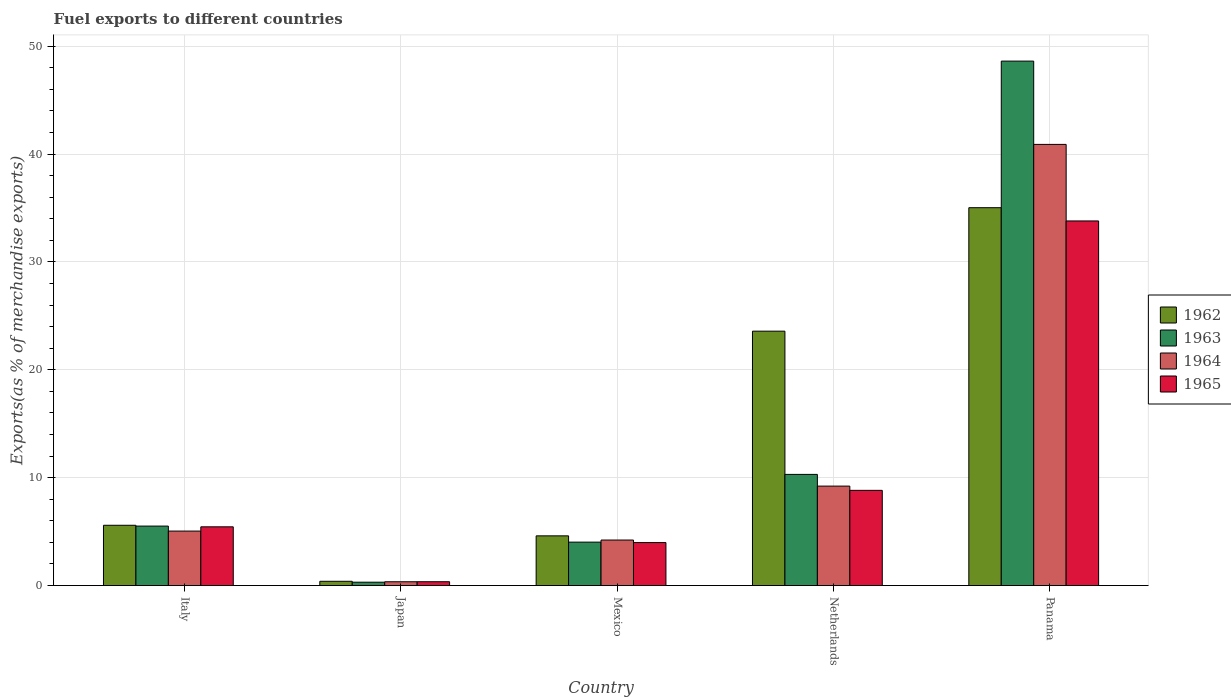How many different coloured bars are there?
Provide a short and direct response. 4. Are the number of bars per tick equal to the number of legend labels?
Your answer should be very brief. Yes. Are the number of bars on each tick of the X-axis equal?
Your response must be concise. Yes. How many bars are there on the 5th tick from the left?
Offer a very short reply. 4. How many bars are there on the 4th tick from the right?
Offer a very short reply. 4. What is the percentage of exports to different countries in 1964 in Japan?
Your response must be concise. 0.35. Across all countries, what is the maximum percentage of exports to different countries in 1965?
Keep it short and to the point. 33.8. Across all countries, what is the minimum percentage of exports to different countries in 1964?
Provide a short and direct response. 0.35. In which country was the percentage of exports to different countries in 1962 maximum?
Your response must be concise. Panama. What is the total percentage of exports to different countries in 1964 in the graph?
Your answer should be very brief. 59.74. What is the difference between the percentage of exports to different countries in 1965 in Japan and that in Mexico?
Your response must be concise. -3.63. What is the difference between the percentage of exports to different countries in 1964 in Japan and the percentage of exports to different countries in 1965 in Netherlands?
Ensure brevity in your answer.  -8.47. What is the average percentage of exports to different countries in 1964 per country?
Offer a terse response. 11.95. What is the difference between the percentage of exports to different countries of/in 1965 and percentage of exports to different countries of/in 1962 in Italy?
Provide a succinct answer. -0.14. What is the ratio of the percentage of exports to different countries in 1964 in Italy to that in Japan?
Your answer should be very brief. 14.31. Is the percentage of exports to different countries in 1965 in Japan less than that in Mexico?
Provide a short and direct response. Yes. Is the difference between the percentage of exports to different countries in 1965 in Italy and Japan greater than the difference between the percentage of exports to different countries in 1962 in Italy and Japan?
Your answer should be compact. No. What is the difference between the highest and the second highest percentage of exports to different countries in 1962?
Ensure brevity in your answer.  29.44. What is the difference between the highest and the lowest percentage of exports to different countries in 1965?
Give a very brief answer. 33.45. Is it the case that in every country, the sum of the percentage of exports to different countries in 1962 and percentage of exports to different countries in 1965 is greater than the sum of percentage of exports to different countries in 1964 and percentage of exports to different countries in 1963?
Give a very brief answer. No. What does the 4th bar from the left in Panama represents?
Offer a very short reply. 1965. What does the 4th bar from the right in Panama represents?
Make the answer very short. 1962. What is the difference between two consecutive major ticks on the Y-axis?
Offer a terse response. 10. Does the graph contain grids?
Your answer should be compact. Yes. How many legend labels are there?
Keep it short and to the point. 4. How are the legend labels stacked?
Give a very brief answer. Vertical. What is the title of the graph?
Provide a succinct answer. Fuel exports to different countries. What is the label or title of the Y-axis?
Offer a very short reply. Exports(as % of merchandise exports). What is the Exports(as % of merchandise exports) in 1962 in Italy?
Ensure brevity in your answer.  5.59. What is the Exports(as % of merchandise exports) of 1963 in Italy?
Your answer should be very brief. 5.51. What is the Exports(as % of merchandise exports) of 1964 in Italy?
Your response must be concise. 5.05. What is the Exports(as % of merchandise exports) in 1965 in Italy?
Your answer should be compact. 5.45. What is the Exports(as % of merchandise exports) in 1962 in Japan?
Your response must be concise. 0.4. What is the Exports(as % of merchandise exports) of 1963 in Japan?
Your answer should be very brief. 0.31. What is the Exports(as % of merchandise exports) in 1964 in Japan?
Your answer should be very brief. 0.35. What is the Exports(as % of merchandise exports) of 1965 in Japan?
Ensure brevity in your answer.  0.36. What is the Exports(as % of merchandise exports) of 1962 in Mexico?
Your answer should be very brief. 4.61. What is the Exports(as % of merchandise exports) in 1963 in Mexico?
Offer a terse response. 4.03. What is the Exports(as % of merchandise exports) in 1964 in Mexico?
Your answer should be compact. 4.22. What is the Exports(as % of merchandise exports) in 1965 in Mexico?
Give a very brief answer. 3.99. What is the Exports(as % of merchandise exports) of 1962 in Netherlands?
Make the answer very short. 23.58. What is the Exports(as % of merchandise exports) of 1963 in Netherlands?
Offer a terse response. 10.31. What is the Exports(as % of merchandise exports) of 1964 in Netherlands?
Ensure brevity in your answer.  9.22. What is the Exports(as % of merchandise exports) of 1965 in Netherlands?
Provide a succinct answer. 8.83. What is the Exports(as % of merchandise exports) of 1962 in Panama?
Give a very brief answer. 35.03. What is the Exports(as % of merchandise exports) of 1963 in Panama?
Provide a succinct answer. 48.62. What is the Exports(as % of merchandise exports) in 1964 in Panama?
Offer a very short reply. 40.9. What is the Exports(as % of merchandise exports) in 1965 in Panama?
Provide a succinct answer. 33.8. Across all countries, what is the maximum Exports(as % of merchandise exports) in 1962?
Your answer should be compact. 35.03. Across all countries, what is the maximum Exports(as % of merchandise exports) of 1963?
Offer a very short reply. 48.62. Across all countries, what is the maximum Exports(as % of merchandise exports) of 1964?
Keep it short and to the point. 40.9. Across all countries, what is the maximum Exports(as % of merchandise exports) of 1965?
Your answer should be compact. 33.8. Across all countries, what is the minimum Exports(as % of merchandise exports) of 1962?
Your answer should be compact. 0.4. Across all countries, what is the minimum Exports(as % of merchandise exports) of 1963?
Offer a very short reply. 0.31. Across all countries, what is the minimum Exports(as % of merchandise exports) of 1964?
Make the answer very short. 0.35. Across all countries, what is the minimum Exports(as % of merchandise exports) of 1965?
Offer a terse response. 0.36. What is the total Exports(as % of merchandise exports) in 1962 in the graph?
Keep it short and to the point. 69.21. What is the total Exports(as % of merchandise exports) in 1963 in the graph?
Provide a short and direct response. 68.78. What is the total Exports(as % of merchandise exports) of 1964 in the graph?
Offer a very short reply. 59.74. What is the total Exports(as % of merchandise exports) in 1965 in the graph?
Your answer should be compact. 52.41. What is the difference between the Exports(as % of merchandise exports) in 1962 in Italy and that in Japan?
Ensure brevity in your answer.  5.19. What is the difference between the Exports(as % of merchandise exports) in 1963 in Italy and that in Japan?
Offer a very short reply. 5.2. What is the difference between the Exports(as % of merchandise exports) in 1964 in Italy and that in Japan?
Ensure brevity in your answer.  4.7. What is the difference between the Exports(as % of merchandise exports) in 1965 in Italy and that in Japan?
Your answer should be compact. 5.09. What is the difference between the Exports(as % of merchandise exports) of 1962 in Italy and that in Mexico?
Offer a terse response. 0.98. What is the difference between the Exports(as % of merchandise exports) of 1963 in Italy and that in Mexico?
Provide a succinct answer. 1.49. What is the difference between the Exports(as % of merchandise exports) in 1964 in Italy and that in Mexico?
Provide a short and direct response. 0.83. What is the difference between the Exports(as % of merchandise exports) in 1965 in Italy and that in Mexico?
Keep it short and to the point. 1.46. What is the difference between the Exports(as % of merchandise exports) of 1962 in Italy and that in Netherlands?
Ensure brevity in your answer.  -17.99. What is the difference between the Exports(as % of merchandise exports) of 1963 in Italy and that in Netherlands?
Your answer should be very brief. -4.79. What is the difference between the Exports(as % of merchandise exports) in 1964 in Italy and that in Netherlands?
Provide a short and direct response. -4.17. What is the difference between the Exports(as % of merchandise exports) of 1965 in Italy and that in Netherlands?
Your response must be concise. -3.38. What is the difference between the Exports(as % of merchandise exports) of 1962 in Italy and that in Panama?
Provide a succinct answer. -29.44. What is the difference between the Exports(as % of merchandise exports) in 1963 in Italy and that in Panama?
Provide a succinct answer. -43.11. What is the difference between the Exports(as % of merchandise exports) of 1964 in Italy and that in Panama?
Give a very brief answer. -35.85. What is the difference between the Exports(as % of merchandise exports) of 1965 in Italy and that in Panama?
Ensure brevity in your answer.  -28.36. What is the difference between the Exports(as % of merchandise exports) in 1962 in Japan and that in Mexico?
Provide a succinct answer. -4.21. What is the difference between the Exports(as % of merchandise exports) of 1963 in Japan and that in Mexico?
Make the answer very short. -3.71. What is the difference between the Exports(as % of merchandise exports) of 1964 in Japan and that in Mexico?
Offer a very short reply. -3.87. What is the difference between the Exports(as % of merchandise exports) of 1965 in Japan and that in Mexico?
Offer a very short reply. -3.63. What is the difference between the Exports(as % of merchandise exports) in 1962 in Japan and that in Netherlands?
Provide a succinct answer. -23.19. What is the difference between the Exports(as % of merchandise exports) in 1963 in Japan and that in Netherlands?
Keep it short and to the point. -9.99. What is the difference between the Exports(as % of merchandise exports) in 1964 in Japan and that in Netherlands?
Make the answer very short. -8.87. What is the difference between the Exports(as % of merchandise exports) in 1965 in Japan and that in Netherlands?
Provide a succinct answer. -8.47. What is the difference between the Exports(as % of merchandise exports) of 1962 in Japan and that in Panama?
Offer a terse response. -34.63. What is the difference between the Exports(as % of merchandise exports) in 1963 in Japan and that in Panama?
Make the answer very short. -48.31. What is the difference between the Exports(as % of merchandise exports) of 1964 in Japan and that in Panama?
Offer a very short reply. -40.54. What is the difference between the Exports(as % of merchandise exports) of 1965 in Japan and that in Panama?
Offer a terse response. -33.45. What is the difference between the Exports(as % of merchandise exports) of 1962 in Mexico and that in Netherlands?
Ensure brevity in your answer.  -18.97. What is the difference between the Exports(as % of merchandise exports) of 1963 in Mexico and that in Netherlands?
Ensure brevity in your answer.  -6.28. What is the difference between the Exports(as % of merchandise exports) in 1964 in Mexico and that in Netherlands?
Give a very brief answer. -5. What is the difference between the Exports(as % of merchandise exports) in 1965 in Mexico and that in Netherlands?
Offer a very short reply. -4.84. What is the difference between the Exports(as % of merchandise exports) of 1962 in Mexico and that in Panama?
Offer a very short reply. -30.42. What is the difference between the Exports(as % of merchandise exports) in 1963 in Mexico and that in Panama?
Provide a short and direct response. -44.59. What is the difference between the Exports(as % of merchandise exports) of 1964 in Mexico and that in Panama?
Provide a succinct answer. -36.68. What is the difference between the Exports(as % of merchandise exports) in 1965 in Mexico and that in Panama?
Your response must be concise. -29.82. What is the difference between the Exports(as % of merchandise exports) of 1962 in Netherlands and that in Panama?
Your answer should be compact. -11.45. What is the difference between the Exports(as % of merchandise exports) of 1963 in Netherlands and that in Panama?
Offer a terse response. -38.32. What is the difference between the Exports(as % of merchandise exports) of 1964 in Netherlands and that in Panama?
Provide a succinct answer. -31.68. What is the difference between the Exports(as % of merchandise exports) of 1965 in Netherlands and that in Panama?
Give a very brief answer. -24.98. What is the difference between the Exports(as % of merchandise exports) of 1962 in Italy and the Exports(as % of merchandise exports) of 1963 in Japan?
Your answer should be compact. 5.28. What is the difference between the Exports(as % of merchandise exports) of 1962 in Italy and the Exports(as % of merchandise exports) of 1964 in Japan?
Your answer should be compact. 5.24. What is the difference between the Exports(as % of merchandise exports) in 1962 in Italy and the Exports(as % of merchandise exports) in 1965 in Japan?
Ensure brevity in your answer.  5.23. What is the difference between the Exports(as % of merchandise exports) of 1963 in Italy and the Exports(as % of merchandise exports) of 1964 in Japan?
Provide a succinct answer. 5.16. What is the difference between the Exports(as % of merchandise exports) of 1963 in Italy and the Exports(as % of merchandise exports) of 1965 in Japan?
Ensure brevity in your answer.  5.16. What is the difference between the Exports(as % of merchandise exports) of 1964 in Italy and the Exports(as % of merchandise exports) of 1965 in Japan?
Your answer should be very brief. 4.7. What is the difference between the Exports(as % of merchandise exports) in 1962 in Italy and the Exports(as % of merchandise exports) in 1963 in Mexico?
Your answer should be compact. 1.56. What is the difference between the Exports(as % of merchandise exports) of 1962 in Italy and the Exports(as % of merchandise exports) of 1964 in Mexico?
Give a very brief answer. 1.37. What is the difference between the Exports(as % of merchandise exports) of 1962 in Italy and the Exports(as % of merchandise exports) of 1965 in Mexico?
Make the answer very short. 1.6. What is the difference between the Exports(as % of merchandise exports) in 1963 in Italy and the Exports(as % of merchandise exports) in 1964 in Mexico?
Provide a short and direct response. 1.29. What is the difference between the Exports(as % of merchandise exports) in 1963 in Italy and the Exports(as % of merchandise exports) in 1965 in Mexico?
Keep it short and to the point. 1.53. What is the difference between the Exports(as % of merchandise exports) in 1964 in Italy and the Exports(as % of merchandise exports) in 1965 in Mexico?
Make the answer very short. 1.07. What is the difference between the Exports(as % of merchandise exports) of 1962 in Italy and the Exports(as % of merchandise exports) of 1963 in Netherlands?
Your answer should be compact. -4.72. What is the difference between the Exports(as % of merchandise exports) of 1962 in Italy and the Exports(as % of merchandise exports) of 1964 in Netherlands?
Your answer should be very brief. -3.63. What is the difference between the Exports(as % of merchandise exports) of 1962 in Italy and the Exports(as % of merchandise exports) of 1965 in Netherlands?
Your response must be concise. -3.24. What is the difference between the Exports(as % of merchandise exports) in 1963 in Italy and the Exports(as % of merchandise exports) in 1964 in Netherlands?
Ensure brevity in your answer.  -3.71. What is the difference between the Exports(as % of merchandise exports) in 1963 in Italy and the Exports(as % of merchandise exports) in 1965 in Netherlands?
Make the answer very short. -3.31. What is the difference between the Exports(as % of merchandise exports) in 1964 in Italy and the Exports(as % of merchandise exports) in 1965 in Netherlands?
Provide a succinct answer. -3.77. What is the difference between the Exports(as % of merchandise exports) of 1962 in Italy and the Exports(as % of merchandise exports) of 1963 in Panama?
Give a very brief answer. -43.03. What is the difference between the Exports(as % of merchandise exports) of 1962 in Italy and the Exports(as % of merchandise exports) of 1964 in Panama?
Your answer should be compact. -35.31. What is the difference between the Exports(as % of merchandise exports) of 1962 in Italy and the Exports(as % of merchandise exports) of 1965 in Panama?
Your answer should be compact. -28.21. What is the difference between the Exports(as % of merchandise exports) of 1963 in Italy and the Exports(as % of merchandise exports) of 1964 in Panama?
Ensure brevity in your answer.  -35.38. What is the difference between the Exports(as % of merchandise exports) of 1963 in Italy and the Exports(as % of merchandise exports) of 1965 in Panama?
Give a very brief answer. -28.29. What is the difference between the Exports(as % of merchandise exports) of 1964 in Italy and the Exports(as % of merchandise exports) of 1965 in Panama?
Your response must be concise. -28.75. What is the difference between the Exports(as % of merchandise exports) of 1962 in Japan and the Exports(as % of merchandise exports) of 1963 in Mexico?
Provide a short and direct response. -3.63. What is the difference between the Exports(as % of merchandise exports) in 1962 in Japan and the Exports(as % of merchandise exports) in 1964 in Mexico?
Offer a very short reply. -3.82. What is the difference between the Exports(as % of merchandise exports) of 1962 in Japan and the Exports(as % of merchandise exports) of 1965 in Mexico?
Keep it short and to the point. -3.59. What is the difference between the Exports(as % of merchandise exports) in 1963 in Japan and the Exports(as % of merchandise exports) in 1964 in Mexico?
Provide a short and direct response. -3.91. What is the difference between the Exports(as % of merchandise exports) in 1963 in Japan and the Exports(as % of merchandise exports) in 1965 in Mexico?
Offer a very short reply. -3.67. What is the difference between the Exports(as % of merchandise exports) in 1964 in Japan and the Exports(as % of merchandise exports) in 1965 in Mexico?
Provide a short and direct response. -3.63. What is the difference between the Exports(as % of merchandise exports) in 1962 in Japan and the Exports(as % of merchandise exports) in 1963 in Netherlands?
Your response must be concise. -9.91. What is the difference between the Exports(as % of merchandise exports) in 1962 in Japan and the Exports(as % of merchandise exports) in 1964 in Netherlands?
Your response must be concise. -8.82. What is the difference between the Exports(as % of merchandise exports) in 1962 in Japan and the Exports(as % of merchandise exports) in 1965 in Netherlands?
Provide a short and direct response. -8.43. What is the difference between the Exports(as % of merchandise exports) of 1963 in Japan and the Exports(as % of merchandise exports) of 1964 in Netherlands?
Provide a succinct answer. -8.91. What is the difference between the Exports(as % of merchandise exports) of 1963 in Japan and the Exports(as % of merchandise exports) of 1965 in Netherlands?
Your answer should be compact. -8.51. What is the difference between the Exports(as % of merchandise exports) in 1964 in Japan and the Exports(as % of merchandise exports) in 1965 in Netherlands?
Offer a terse response. -8.47. What is the difference between the Exports(as % of merchandise exports) in 1962 in Japan and the Exports(as % of merchandise exports) in 1963 in Panama?
Ensure brevity in your answer.  -48.22. What is the difference between the Exports(as % of merchandise exports) in 1962 in Japan and the Exports(as % of merchandise exports) in 1964 in Panama?
Provide a succinct answer. -40.5. What is the difference between the Exports(as % of merchandise exports) in 1962 in Japan and the Exports(as % of merchandise exports) in 1965 in Panama?
Make the answer very short. -33.41. What is the difference between the Exports(as % of merchandise exports) of 1963 in Japan and the Exports(as % of merchandise exports) of 1964 in Panama?
Offer a very short reply. -40.58. What is the difference between the Exports(as % of merchandise exports) in 1963 in Japan and the Exports(as % of merchandise exports) in 1965 in Panama?
Provide a succinct answer. -33.49. What is the difference between the Exports(as % of merchandise exports) in 1964 in Japan and the Exports(as % of merchandise exports) in 1965 in Panama?
Your answer should be very brief. -33.45. What is the difference between the Exports(as % of merchandise exports) of 1962 in Mexico and the Exports(as % of merchandise exports) of 1963 in Netherlands?
Ensure brevity in your answer.  -5.7. What is the difference between the Exports(as % of merchandise exports) in 1962 in Mexico and the Exports(as % of merchandise exports) in 1964 in Netherlands?
Provide a short and direct response. -4.61. What is the difference between the Exports(as % of merchandise exports) of 1962 in Mexico and the Exports(as % of merchandise exports) of 1965 in Netherlands?
Your answer should be very brief. -4.22. What is the difference between the Exports(as % of merchandise exports) of 1963 in Mexico and the Exports(as % of merchandise exports) of 1964 in Netherlands?
Give a very brief answer. -5.19. What is the difference between the Exports(as % of merchandise exports) of 1963 in Mexico and the Exports(as % of merchandise exports) of 1965 in Netherlands?
Offer a very short reply. -4.8. What is the difference between the Exports(as % of merchandise exports) in 1964 in Mexico and the Exports(as % of merchandise exports) in 1965 in Netherlands?
Make the answer very short. -4.61. What is the difference between the Exports(as % of merchandise exports) in 1962 in Mexico and the Exports(as % of merchandise exports) in 1963 in Panama?
Your answer should be compact. -44.01. What is the difference between the Exports(as % of merchandise exports) of 1962 in Mexico and the Exports(as % of merchandise exports) of 1964 in Panama?
Provide a short and direct response. -36.29. What is the difference between the Exports(as % of merchandise exports) of 1962 in Mexico and the Exports(as % of merchandise exports) of 1965 in Panama?
Ensure brevity in your answer.  -29.19. What is the difference between the Exports(as % of merchandise exports) in 1963 in Mexico and the Exports(as % of merchandise exports) in 1964 in Panama?
Keep it short and to the point. -36.87. What is the difference between the Exports(as % of merchandise exports) in 1963 in Mexico and the Exports(as % of merchandise exports) in 1965 in Panama?
Ensure brevity in your answer.  -29.78. What is the difference between the Exports(as % of merchandise exports) in 1964 in Mexico and the Exports(as % of merchandise exports) in 1965 in Panama?
Provide a succinct answer. -29.58. What is the difference between the Exports(as % of merchandise exports) of 1962 in Netherlands and the Exports(as % of merchandise exports) of 1963 in Panama?
Your answer should be compact. -25.04. What is the difference between the Exports(as % of merchandise exports) of 1962 in Netherlands and the Exports(as % of merchandise exports) of 1964 in Panama?
Offer a very short reply. -17.31. What is the difference between the Exports(as % of merchandise exports) in 1962 in Netherlands and the Exports(as % of merchandise exports) in 1965 in Panama?
Your response must be concise. -10.22. What is the difference between the Exports(as % of merchandise exports) in 1963 in Netherlands and the Exports(as % of merchandise exports) in 1964 in Panama?
Make the answer very short. -30.59. What is the difference between the Exports(as % of merchandise exports) of 1963 in Netherlands and the Exports(as % of merchandise exports) of 1965 in Panama?
Provide a short and direct response. -23.5. What is the difference between the Exports(as % of merchandise exports) of 1964 in Netherlands and the Exports(as % of merchandise exports) of 1965 in Panama?
Your response must be concise. -24.58. What is the average Exports(as % of merchandise exports) of 1962 per country?
Offer a very short reply. 13.84. What is the average Exports(as % of merchandise exports) in 1963 per country?
Provide a succinct answer. 13.76. What is the average Exports(as % of merchandise exports) of 1964 per country?
Ensure brevity in your answer.  11.95. What is the average Exports(as % of merchandise exports) in 1965 per country?
Your answer should be very brief. 10.48. What is the difference between the Exports(as % of merchandise exports) of 1962 and Exports(as % of merchandise exports) of 1963 in Italy?
Offer a terse response. 0.08. What is the difference between the Exports(as % of merchandise exports) of 1962 and Exports(as % of merchandise exports) of 1964 in Italy?
Provide a short and direct response. 0.54. What is the difference between the Exports(as % of merchandise exports) of 1962 and Exports(as % of merchandise exports) of 1965 in Italy?
Offer a terse response. 0.14. What is the difference between the Exports(as % of merchandise exports) of 1963 and Exports(as % of merchandise exports) of 1964 in Italy?
Provide a succinct answer. 0.46. What is the difference between the Exports(as % of merchandise exports) in 1963 and Exports(as % of merchandise exports) in 1965 in Italy?
Offer a terse response. 0.07. What is the difference between the Exports(as % of merchandise exports) of 1964 and Exports(as % of merchandise exports) of 1965 in Italy?
Provide a succinct answer. -0.39. What is the difference between the Exports(as % of merchandise exports) in 1962 and Exports(as % of merchandise exports) in 1963 in Japan?
Ensure brevity in your answer.  0.08. What is the difference between the Exports(as % of merchandise exports) in 1962 and Exports(as % of merchandise exports) in 1964 in Japan?
Your answer should be compact. 0.04. What is the difference between the Exports(as % of merchandise exports) in 1962 and Exports(as % of merchandise exports) in 1965 in Japan?
Your answer should be compact. 0.04. What is the difference between the Exports(as % of merchandise exports) in 1963 and Exports(as % of merchandise exports) in 1964 in Japan?
Your answer should be very brief. -0.04. What is the difference between the Exports(as % of merchandise exports) of 1963 and Exports(as % of merchandise exports) of 1965 in Japan?
Your response must be concise. -0.04. What is the difference between the Exports(as % of merchandise exports) in 1964 and Exports(as % of merchandise exports) in 1965 in Japan?
Provide a succinct answer. -0. What is the difference between the Exports(as % of merchandise exports) of 1962 and Exports(as % of merchandise exports) of 1963 in Mexico?
Provide a succinct answer. 0.58. What is the difference between the Exports(as % of merchandise exports) in 1962 and Exports(as % of merchandise exports) in 1964 in Mexico?
Your answer should be compact. 0.39. What is the difference between the Exports(as % of merchandise exports) of 1962 and Exports(as % of merchandise exports) of 1965 in Mexico?
Keep it short and to the point. 0.62. What is the difference between the Exports(as % of merchandise exports) in 1963 and Exports(as % of merchandise exports) in 1964 in Mexico?
Your response must be concise. -0.19. What is the difference between the Exports(as % of merchandise exports) of 1963 and Exports(as % of merchandise exports) of 1965 in Mexico?
Offer a very short reply. 0.04. What is the difference between the Exports(as % of merchandise exports) in 1964 and Exports(as % of merchandise exports) in 1965 in Mexico?
Your response must be concise. 0.23. What is the difference between the Exports(as % of merchandise exports) of 1962 and Exports(as % of merchandise exports) of 1963 in Netherlands?
Offer a terse response. 13.28. What is the difference between the Exports(as % of merchandise exports) of 1962 and Exports(as % of merchandise exports) of 1964 in Netherlands?
Your response must be concise. 14.36. What is the difference between the Exports(as % of merchandise exports) of 1962 and Exports(as % of merchandise exports) of 1965 in Netherlands?
Your answer should be compact. 14.76. What is the difference between the Exports(as % of merchandise exports) in 1963 and Exports(as % of merchandise exports) in 1964 in Netherlands?
Keep it short and to the point. 1.09. What is the difference between the Exports(as % of merchandise exports) in 1963 and Exports(as % of merchandise exports) in 1965 in Netherlands?
Offer a very short reply. 1.48. What is the difference between the Exports(as % of merchandise exports) in 1964 and Exports(as % of merchandise exports) in 1965 in Netherlands?
Offer a terse response. 0.39. What is the difference between the Exports(as % of merchandise exports) in 1962 and Exports(as % of merchandise exports) in 1963 in Panama?
Ensure brevity in your answer.  -13.59. What is the difference between the Exports(as % of merchandise exports) in 1962 and Exports(as % of merchandise exports) in 1964 in Panama?
Provide a succinct answer. -5.87. What is the difference between the Exports(as % of merchandise exports) in 1962 and Exports(as % of merchandise exports) in 1965 in Panama?
Ensure brevity in your answer.  1.23. What is the difference between the Exports(as % of merchandise exports) in 1963 and Exports(as % of merchandise exports) in 1964 in Panama?
Give a very brief answer. 7.72. What is the difference between the Exports(as % of merchandise exports) in 1963 and Exports(as % of merchandise exports) in 1965 in Panama?
Offer a terse response. 14.82. What is the difference between the Exports(as % of merchandise exports) in 1964 and Exports(as % of merchandise exports) in 1965 in Panama?
Your answer should be compact. 7.1. What is the ratio of the Exports(as % of merchandise exports) of 1962 in Italy to that in Japan?
Your answer should be very brief. 14.1. What is the ratio of the Exports(as % of merchandise exports) of 1963 in Italy to that in Japan?
Give a very brief answer. 17.64. What is the ratio of the Exports(as % of merchandise exports) in 1964 in Italy to that in Japan?
Give a very brief answer. 14.31. What is the ratio of the Exports(as % of merchandise exports) in 1965 in Italy to that in Japan?
Your answer should be compact. 15.32. What is the ratio of the Exports(as % of merchandise exports) of 1962 in Italy to that in Mexico?
Keep it short and to the point. 1.21. What is the ratio of the Exports(as % of merchandise exports) in 1963 in Italy to that in Mexico?
Offer a terse response. 1.37. What is the ratio of the Exports(as % of merchandise exports) of 1964 in Italy to that in Mexico?
Offer a very short reply. 1.2. What is the ratio of the Exports(as % of merchandise exports) in 1965 in Italy to that in Mexico?
Keep it short and to the point. 1.37. What is the ratio of the Exports(as % of merchandise exports) in 1962 in Italy to that in Netherlands?
Keep it short and to the point. 0.24. What is the ratio of the Exports(as % of merchandise exports) in 1963 in Italy to that in Netherlands?
Provide a succinct answer. 0.54. What is the ratio of the Exports(as % of merchandise exports) in 1964 in Italy to that in Netherlands?
Your answer should be compact. 0.55. What is the ratio of the Exports(as % of merchandise exports) in 1965 in Italy to that in Netherlands?
Keep it short and to the point. 0.62. What is the ratio of the Exports(as % of merchandise exports) in 1962 in Italy to that in Panama?
Make the answer very short. 0.16. What is the ratio of the Exports(as % of merchandise exports) of 1963 in Italy to that in Panama?
Your answer should be compact. 0.11. What is the ratio of the Exports(as % of merchandise exports) in 1964 in Italy to that in Panama?
Keep it short and to the point. 0.12. What is the ratio of the Exports(as % of merchandise exports) in 1965 in Italy to that in Panama?
Make the answer very short. 0.16. What is the ratio of the Exports(as % of merchandise exports) of 1962 in Japan to that in Mexico?
Make the answer very short. 0.09. What is the ratio of the Exports(as % of merchandise exports) of 1963 in Japan to that in Mexico?
Offer a terse response. 0.08. What is the ratio of the Exports(as % of merchandise exports) of 1964 in Japan to that in Mexico?
Offer a terse response. 0.08. What is the ratio of the Exports(as % of merchandise exports) in 1965 in Japan to that in Mexico?
Provide a short and direct response. 0.09. What is the ratio of the Exports(as % of merchandise exports) in 1962 in Japan to that in Netherlands?
Your answer should be compact. 0.02. What is the ratio of the Exports(as % of merchandise exports) in 1963 in Japan to that in Netherlands?
Provide a succinct answer. 0.03. What is the ratio of the Exports(as % of merchandise exports) of 1964 in Japan to that in Netherlands?
Provide a short and direct response. 0.04. What is the ratio of the Exports(as % of merchandise exports) in 1965 in Japan to that in Netherlands?
Provide a succinct answer. 0.04. What is the ratio of the Exports(as % of merchandise exports) of 1962 in Japan to that in Panama?
Keep it short and to the point. 0.01. What is the ratio of the Exports(as % of merchandise exports) of 1963 in Japan to that in Panama?
Offer a very short reply. 0.01. What is the ratio of the Exports(as % of merchandise exports) in 1964 in Japan to that in Panama?
Offer a very short reply. 0.01. What is the ratio of the Exports(as % of merchandise exports) of 1965 in Japan to that in Panama?
Offer a terse response. 0.01. What is the ratio of the Exports(as % of merchandise exports) in 1962 in Mexico to that in Netherlands?
Give a very brief answer. 0.2. What is the ratio of the Exports(as % of merchandise exports) of 1963 in Mexico to that in Netherlands?
Provide a succinct answer. 0.39. What is the ratio of the Exports(as % of merchandise exports) in 1964 in Mexico to that in Netherlands?
Offer a terse response. 0.46. What is the ratio of the Exports(as % of merchandise exports) in 1965 in Mexico to that in Netherlands?
Give a very brief answer. 0.45. What is the ratio of the Exports(as % of merchandise exports) in 1962 in Mexico to that in Panama?
Ensure brevity in your answer.  0.13. What is the ratio of the Exports(as % of merchandise exports) of 1963 in Mexico to that in Panama?
Your answer should be very brief. 0.08. What is the ratio of the Exports(as % of merchandise exports) in 1964 in Mexico to that in Panama?
Offer a very short reply. 0.1. What is the ratio of the Exports(as % of merchandise exports) of 1965 in Mexico to that in Panama?
Your answer should be very brief. 0.12. What is the ratio of the Exports(as % of merchandise exports) of 1962 in Netherlands to that in Panama?
Provide a succinct answer. 0.67. What is the ratio of the Exports(as % of merchandise exports) of 1963 in Netherlands to that in Panama?
Keep it short and to the point. 0.21. What is the ratio of the Exports(as % of merchandise exports) in 1964 in Netherlands to that in Panama?
Keep it short and to the point. 0.23. What is the ratio of the Exports(as % of merchandise exports) of 1965 in Netherlands to that in Panama?
Keep it short and to the point. 0.26. What is the difference between the highest and the second highest Exports(as % of merchandise exports) of 1962?
Provide a succinct answer. 11.45. What is the difference between the highest and the second highest Exports(as % of merchandise exports) in 1963?
Offer a very short reply. 38.32. What is the difference between the highest and the second highest Exports(as % of merchandise exports) of 1964?
Offer a very short reply. 31.68. What is the difference between the highest and the second highest Exports(as % of merchandise exports) of 1965?
Keep it short and to the point. 24.98. What is the difference between the highest and the lowest Exports(as % of merchandise exports) in 1962?
Make the answer very short. 34.63. What is the difference between the highest and the lowest Exports(as % of merchandise exports) of 1963?
Provide a short and direct response. 48.31. What is the difference between the highest and the lowest Exports(as % of merchandise exports) of 1964?
Provide a succinct answer. 40.54. What is the difference between the highest and the lowest Exports(as % of merchandise exports) of 1965?
Offer a terse response. 33.45. 